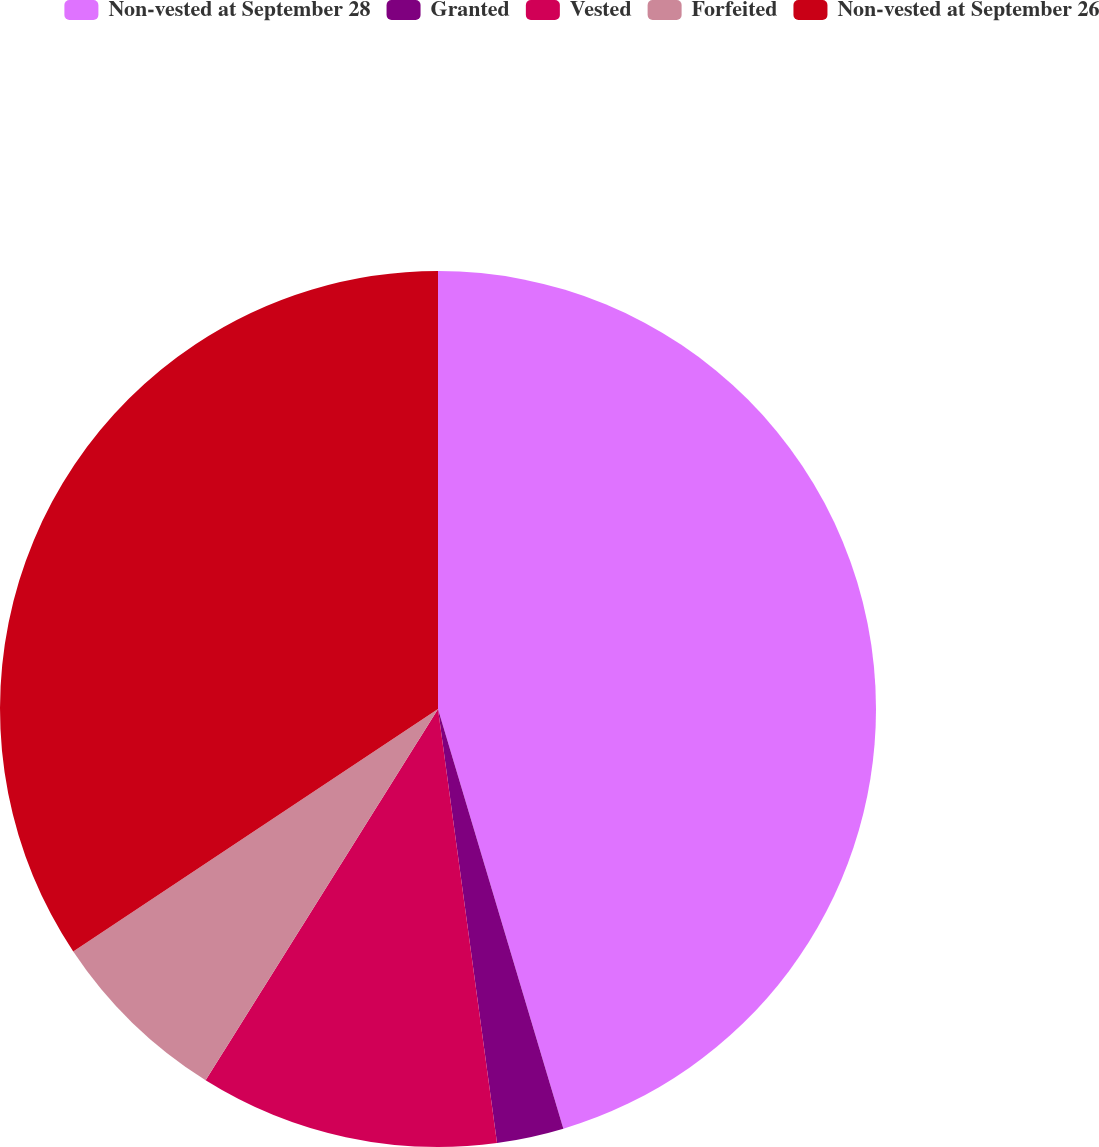<chart> <loc_0><loc_0><loc_500><loc_500><pie_chart><fcel>Non-vested at September 28<fcel>Granted<fcel>Vested<fcel>Forfeited<fcel>Non-vested at September 26<nl><fcel>45.37%<fcel>2.47%<fcel>11.05%<fcel>6.76%<fcel>34.33%<nl></chart> 